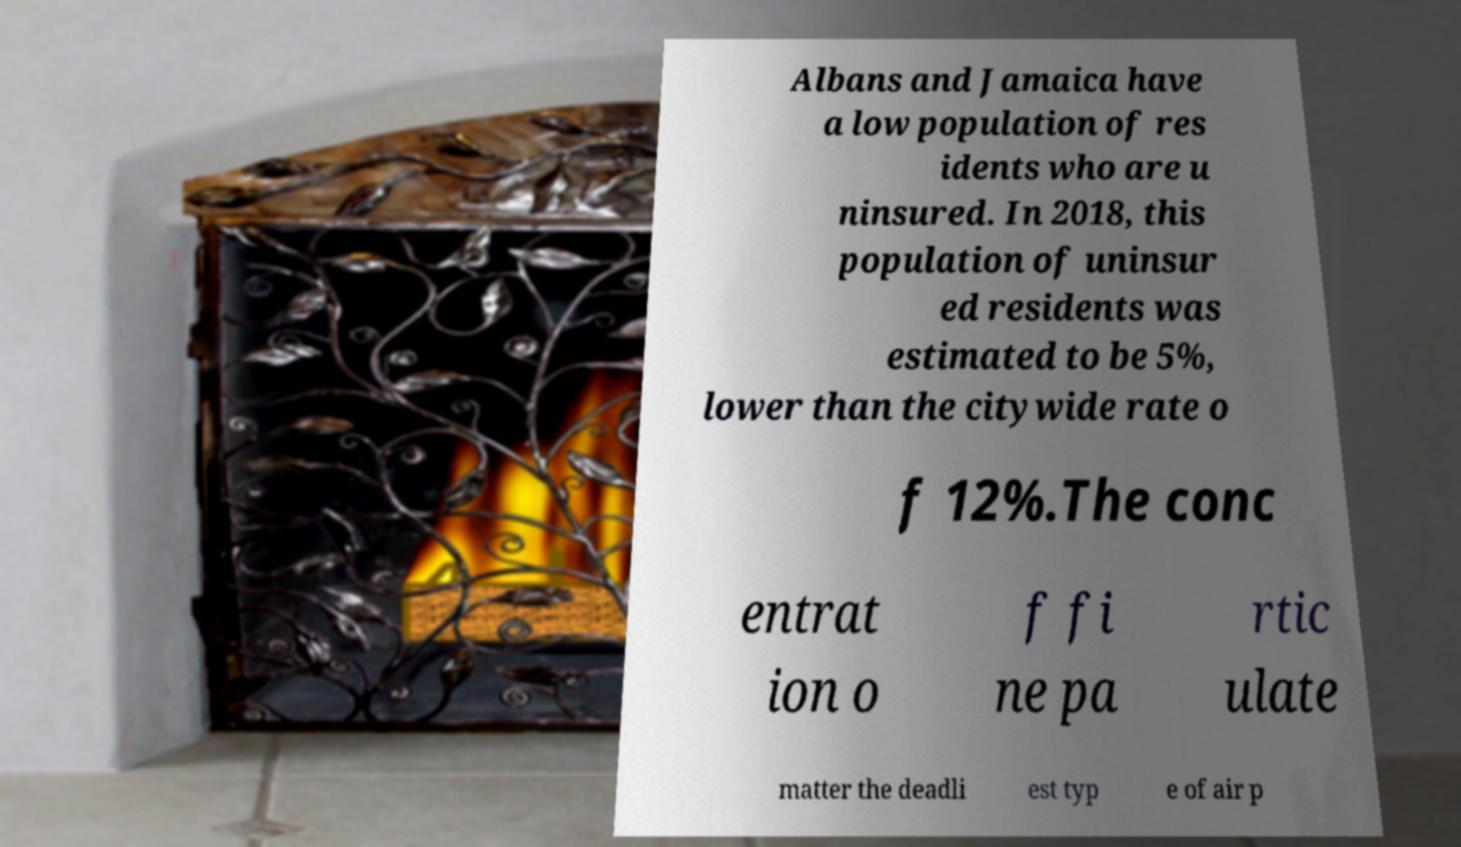I need the written content from this picture converted into text. Can you do that? Albans and Jamaica have a low population of res idents who are u ninsured. In 2018, this population of uninsur ed residents was estimated to be 5%, lower than the citywide rate o f 12%.The conc entrat ion o f fi ne pa rtic ulate matter the deadli est typ e of air p 